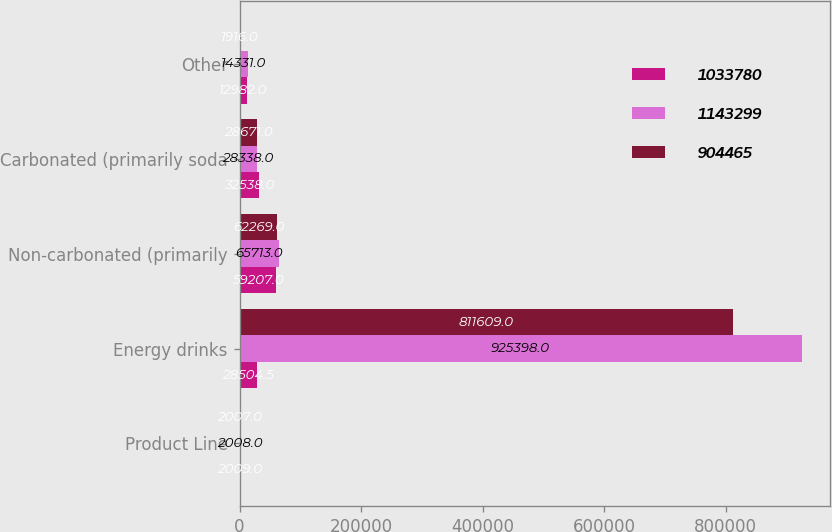<chart> <loc_0><loc_0><loc_500><loc_500><stacked_bar_chart><ecel><fcel>Product Line<fcel>Energy drinks<fcel>Non-carbonated (primarily<fcel>Carbonated (primarily soda<fcel>Other<nl><fcel>1.03378e+06<fcel>2009<fcel>28504.5<fcel>59207<fcel>32538<fcel>12982<nl><fcel>1.1433e+06<fcel>2008<fcel>925398<fcel>65713<fcel>28338<fcel>14331<nl><fcel>904465<fcel>2007<fcel>811609<fcel>62269<fcel>28671<fcel>1916<nl></chart> 